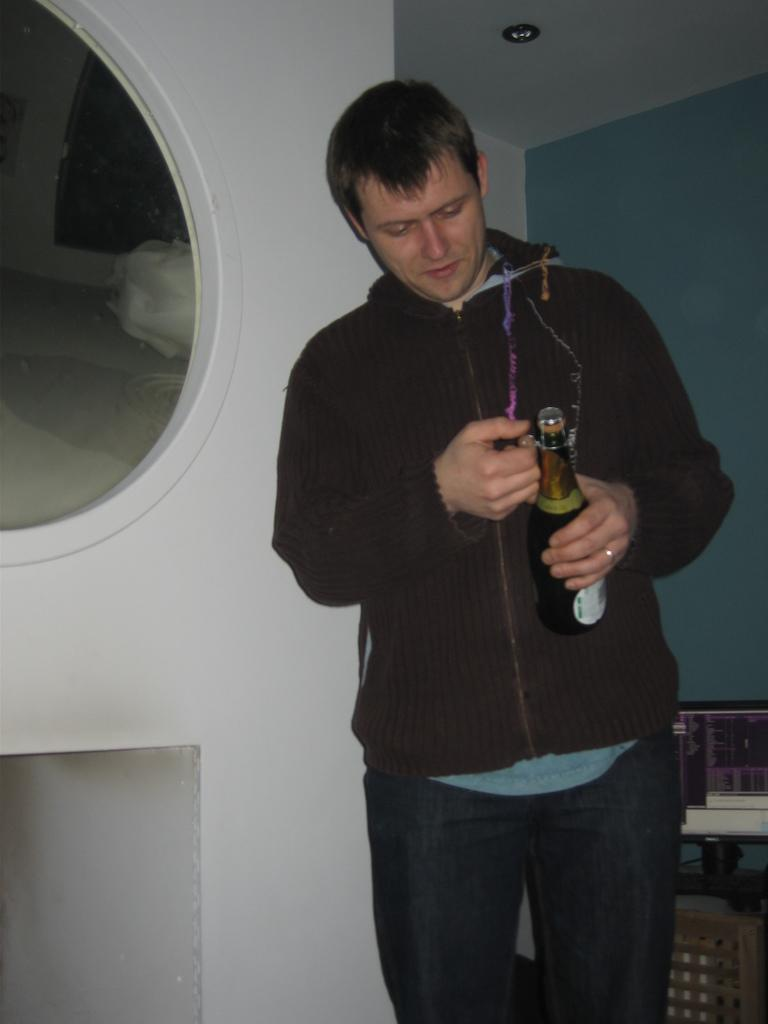What is present in the image? There is a person in the image. Can you describe the position of the person in the image? The person is standing on the right side of the image. What is the person holding in his hand? The person is holding a wine bottle in his hand. What type of jewel is the person wearing on their forehead in the image? There is no jewel visible on the person's forehead in the image. How many balloons are tied to the person's wrist in the image? There are no balloons present in the image. 